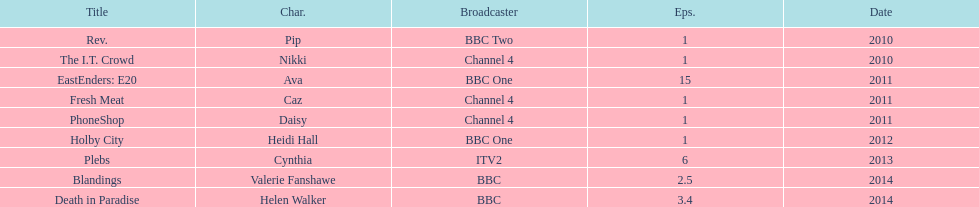What is the only role she played with broadcaster itv2? Cynthia. 